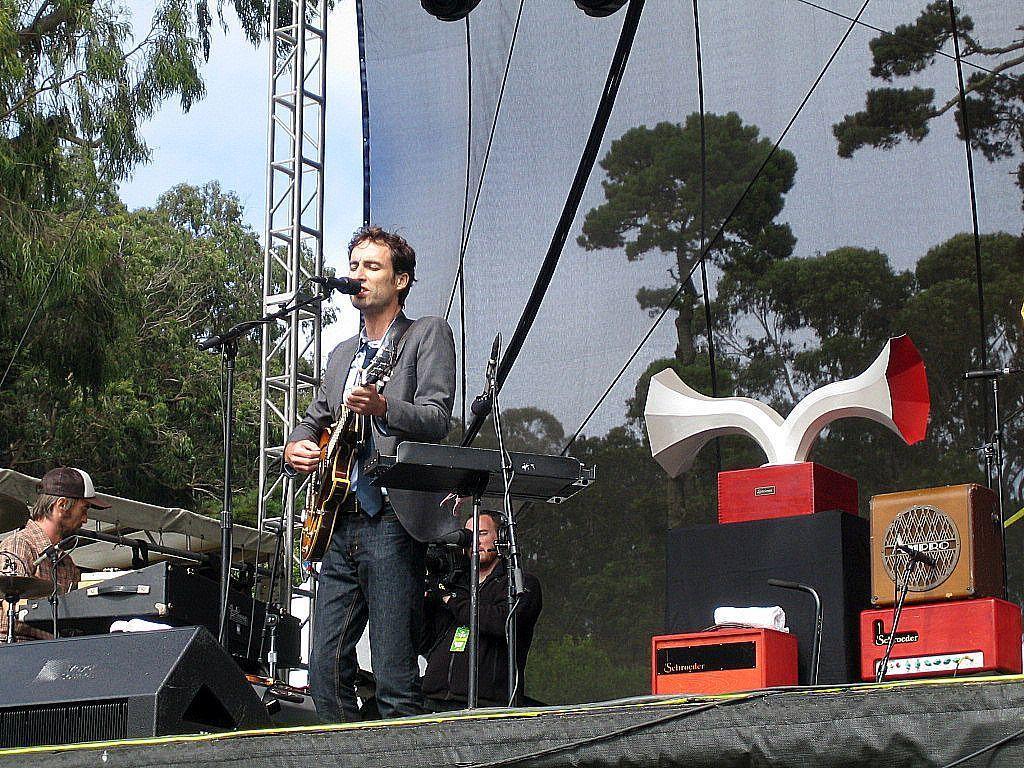Could you give a brief overview of what you see in this image? In this image there is a person singing by playing the guitar in front of a mic on the stage, behind the person there is another person playing a piano and there is another person video graphing, behind them there are a few other musical instruments and a big banner and a metal structure, beside the metal structure there are trees. 